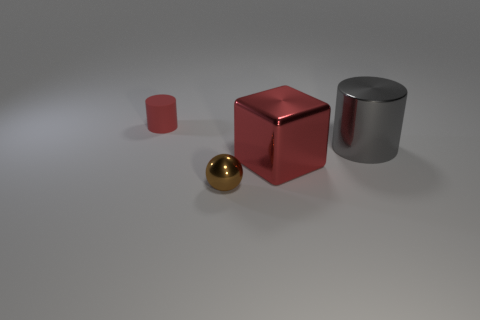Are there more tiny brown shiny balls that are behind the tiny brown metallic thing than large red blocks that are to the left of the big metallic block?
Your answer should be very brief. No. What is the material of the brown object that is the same size as the red matte cylinder?
Ensure brevity in your answer.  Metal. How many big things are either shiny cubes or shiny things?
Provide a short and direct response. 2. Is the shape of the gray thing the same as the small brown shiny thing?
Keep it short and to the point. No. What number of red objects are both to the right of the brown object and on the left side of the small sphere?
Your answer should be very brief. 0. Is there any other thing that is the same color as the tiny metal ball?
Give a very brief answer. No. What is the shape of the small thing that is made of the same material as the big gray thing?
Offer a very short reply. Sphere. Is the gray metallic thing the same size as the red metal object?
Keep it short and to the point. Yes. Is the cylinder that is left of the big red block made of the same material as the big cylinder?
Make the answer very short. No. Are there any other things that have the same material as the big red cube?
Ensure brevity in your answer.  Yes. 